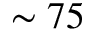<formula> <loc_0><loc_0><loc_500><loc_500>\sim 7 5</formula> 